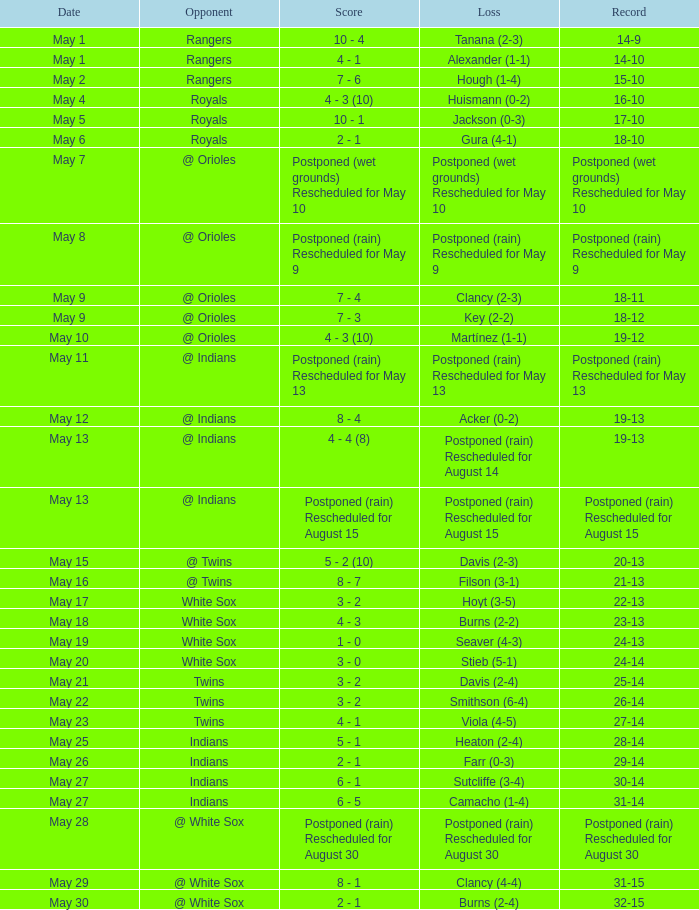What was the loss of the game when the record was 21-13? Filson (3-1). 